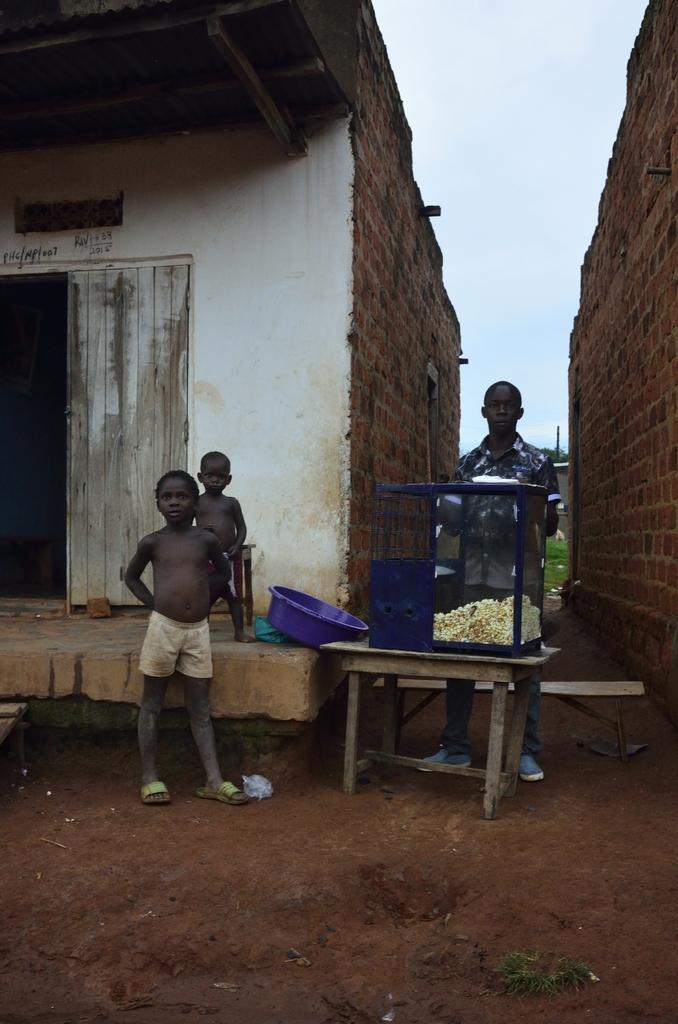In one or two sentences, can you explain what this image depicts? In the foreground of this picture, there are three persons, one man and two boys standing and there is a pop corn counter in front of the man. In the background, there are buildings and the sky. 